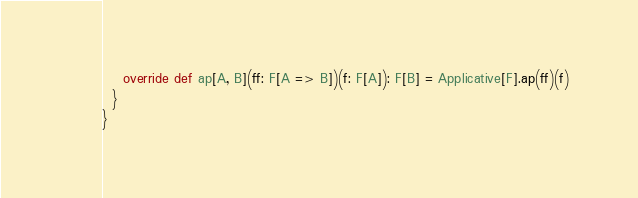<code> <loc_0><loc_0><loc_500><loc_500><_Scala_>    override def ap[A, B](ff: F[A => B])(f: F[A]): F[B] = Applicative[F].ap(ff)(f)
  }
}</code> 